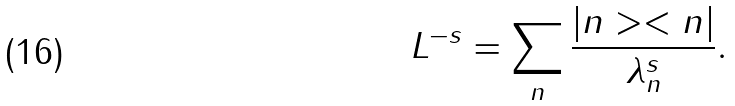Convert formula to latex. <formula><loc_0><loc_0><loc_500><loc_500>L ^ { - s } = \sum _ { n } \frac { | n > < n | } { \lambda _ { n } ^ { s } } .</formula> 